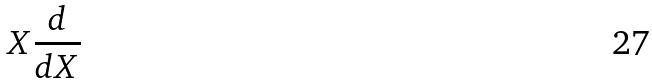<formula> <loc_0><loc_0><loc_500><loc_500>X \frac { d } { d X }</formula> 